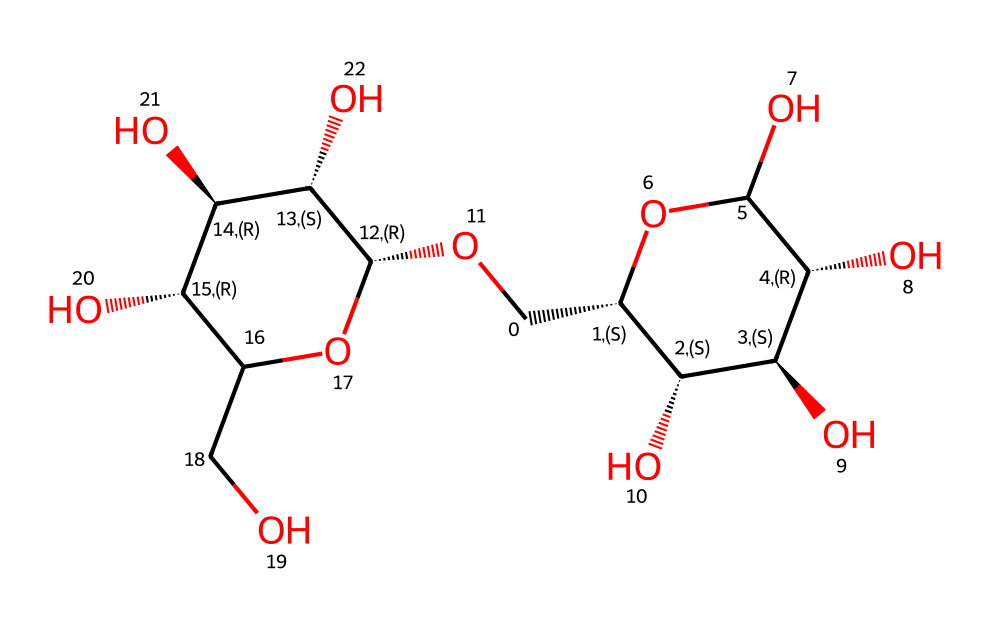How many carbon atoms are present in this chemical? To determine the number of carbon atoms, we analyze the SMILES representation and count the 'C' characters. Each 'C' represents a carbon atom. In the provided SMILES, there are 12 carbon atoms.
Answer: 12 What is the main functional group present in this structure? By examining the chemical structure, specifically the hydroxyl groups (-OH), we can identify that this carbohydrate contains multiple hydroxyl groups as its main functional group, which is characteristic of sugars and polysaccharides like cellulose.
Answer: hydroxyl groups How many hydroxyl (-OH) groups are present in this cellulose structure? We locate each instance of 'O' followed by a hydrogen atom 'H' in the SMILES notation. In this molecule, there are 6 -OH groups associated with the carbon atoms.
Answer: 6 What is the type of linkage connecting the monosaccharide units in cellulose? The structural representation suggests that the cellulose is made of beta-1,4-glycosidic linkages, which link the monosaccharide units together. This is focused on the orientation of the hydroxyl groups on the carbon atoms.
Answer: beta-1,4-glycosidic What type of carbohydrate does this chemical represent? By identifying the structure and connections, we see that cellulose is a polysaccharide characterized by multiple glucose units linked together. Thus, it is classified as a polysaccharide.
Answer: polysaccharide How many oxygen atoms are present in this chemical structure? To find the number of oxygen atoms, we count the 'O' characters in the SMILES. The provided chemical structure contains 6 oxygen atoms.
Answer: 6 What is the overall geometry of the cellulose molecule indicated by the structure? The structure displays a linear and branched geometry, typical of cellulose. Counting the bonds and analyzing the angles formed by the carbon and oxygen atoms supports this conclusion.
Answer: linear and branched 